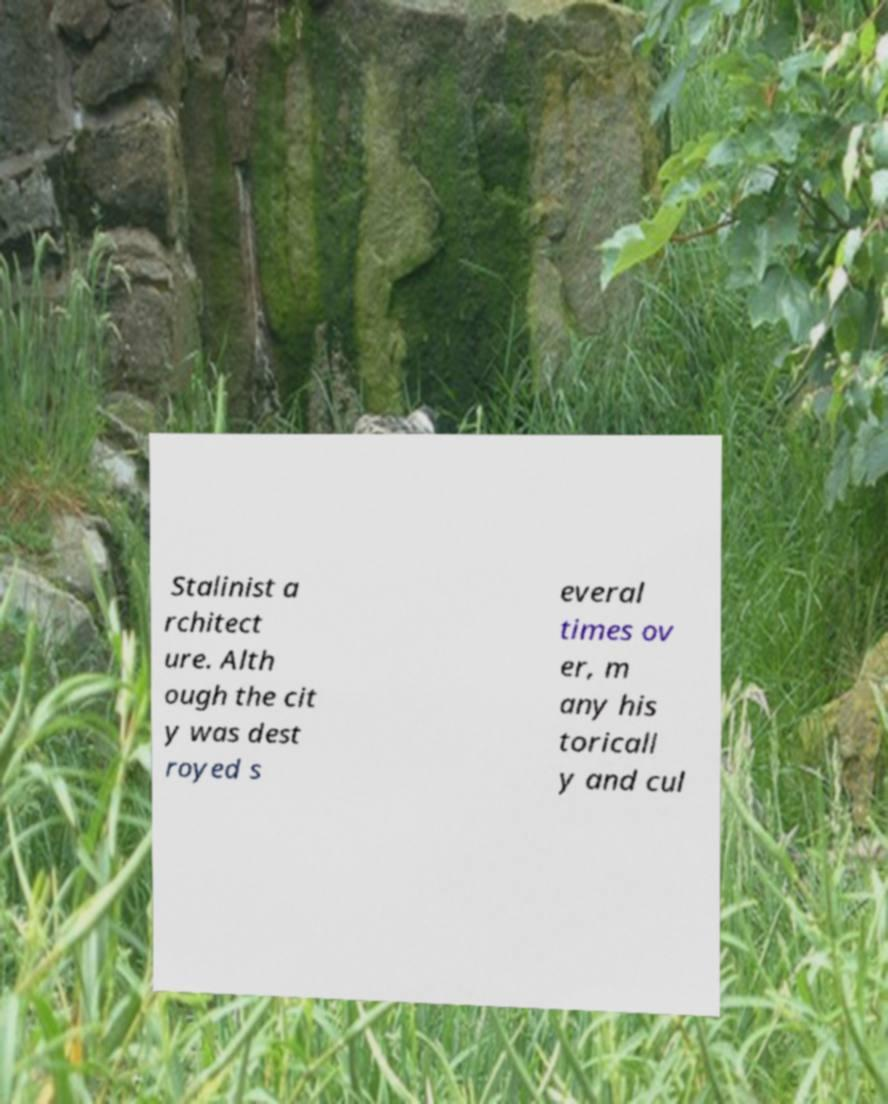There's text embedded in this image that I need extracted. Can you transcribe it verbatim? Stalinist a rchitect ure. Alth ough the cit y was dest royed s everal times ov er, m any his toricall y and cul 